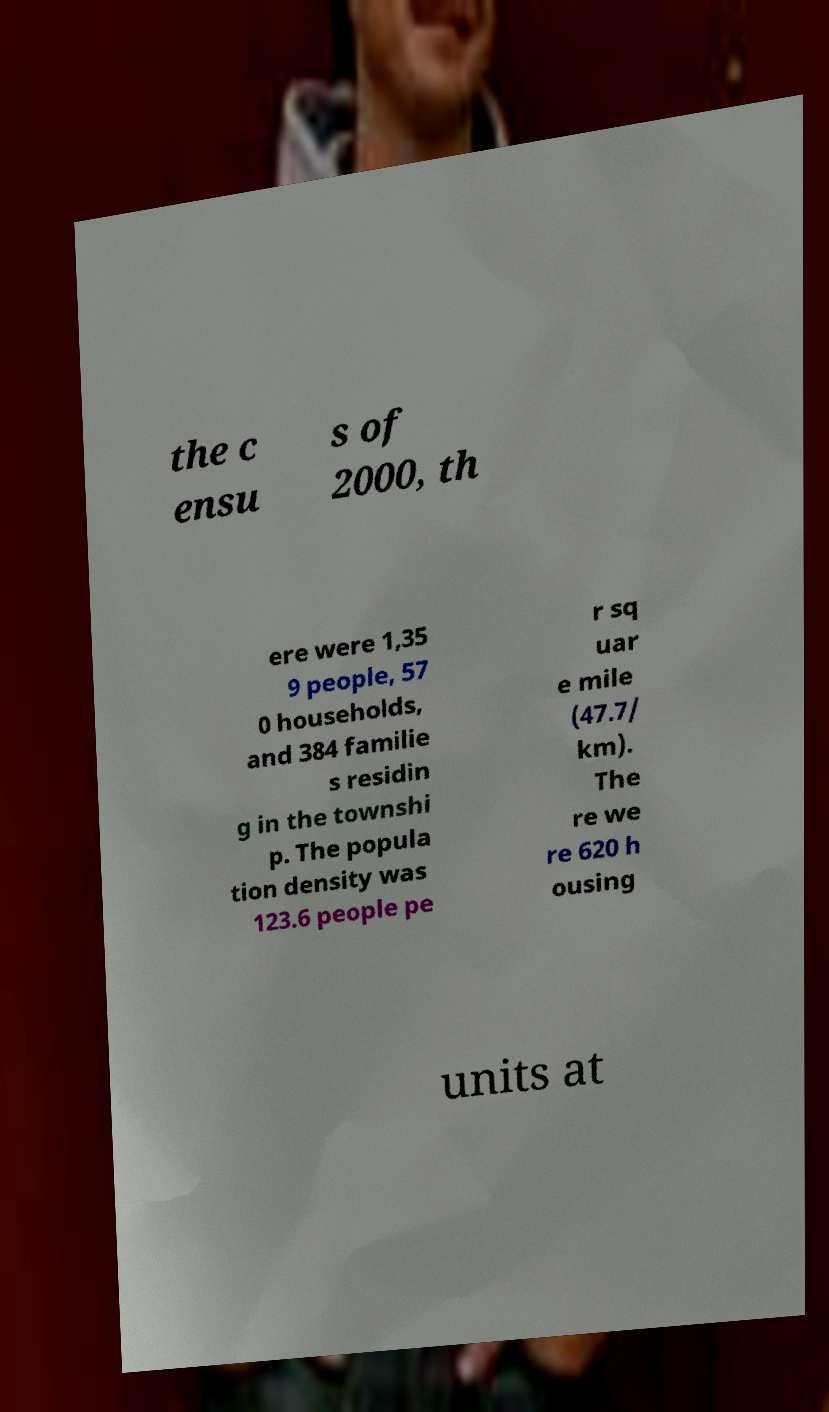Could you extract and type out the text from this image? the c ensu s of 2000, th ere were 1,35 9 people, 57 0 households, and 384 familie s residin g in the townshi p. The popula tion density was 123.6 people pe r sq uar e mile (47.7/ km). The re we re 620 h ousing units at 